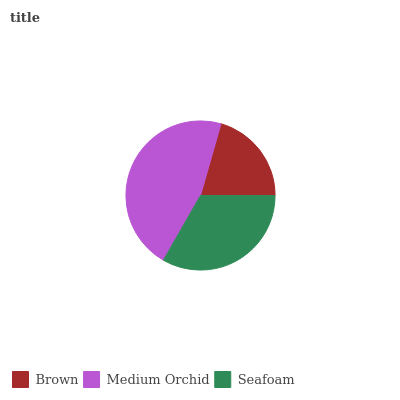Is Brown the minimum?
Answer yes or no. Yes. Is Medium Orchid the maximum?
Answer yes or no. Yes. Is Seafoam the minimum?
Answer yes or no. No. Is Seafoam the maximum?
Answer yes or no. No. Is Medium Orchid greater than Seafoam?
Answer yes or no. Yes. Is Seafoam less than Medium Orchid?
Answer yes or no. Yes. Is Seafoam greater than Medium Orchid?
Answer yes or no. No. Is Medium Orchid less than Seafoam?
Answer yes or no. No. Is Seafoam the high median?
Answer yes or no. Yes. Is Seafoam the low median?
Answer yes or no. Yes. Is Medium Orchid the high median?
Answer yes or no. No. Is Brown the low median?
Answer yes or no. No. 